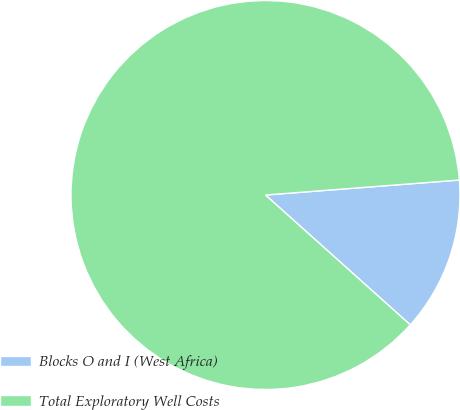<chart> <loc_0><loc_0><loc_500><loc_500><pie_chart><fcel>Blocks O and I (West Africa)<fcel>Total Exploratory Well Costs<nl><fcel>12.86%<fcel>87.14%<nl></chart> 